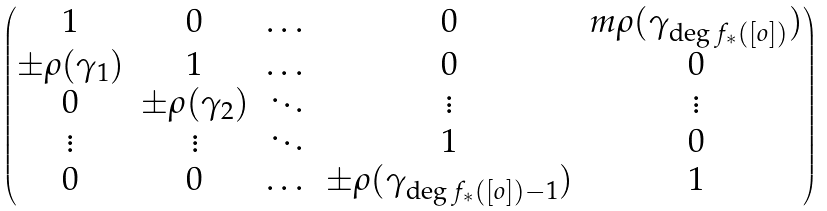<formula> <loc_0><loc_0><loc_500><loc_500>\begin{pmatrix} 1 & 0 & \dots & 0 & m \rho ( \gamma _ { \deg f _ { * } ( [ o ] ) } ) \\ \pm \rho ( \gamma _ { 1 } ) & 1 & \dots & 0 & 0 \\ 0 & \pm \rho ( \gamma _ { 2 } ) & \ddots & \vdots & \vdots \\ \vdots & \vdots & \ddots & 1 & 0 \\ 0 & 0 & \dots & \pm \rho ( \gamma _ { \deg f _ { * } ( [ o ] ) - 1 } ) & 1 \end{pmatrix}</formula> 